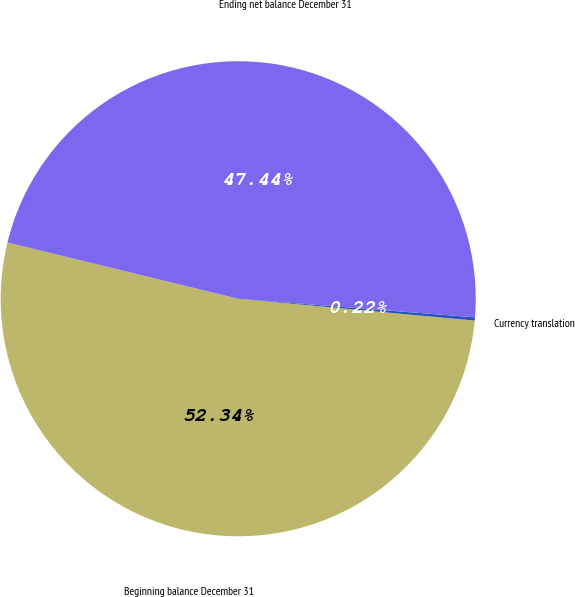Convert chart. <chart><loc_0><loc_0><loc_500><loc_500><pie_chart><fcel>Beginning balance December 31<fcel>Currency translation<fcel>Ending net balance December 31<nl><fcel>52.34%<fcel>0.22%<fcel>47.44%<nl></chart> 